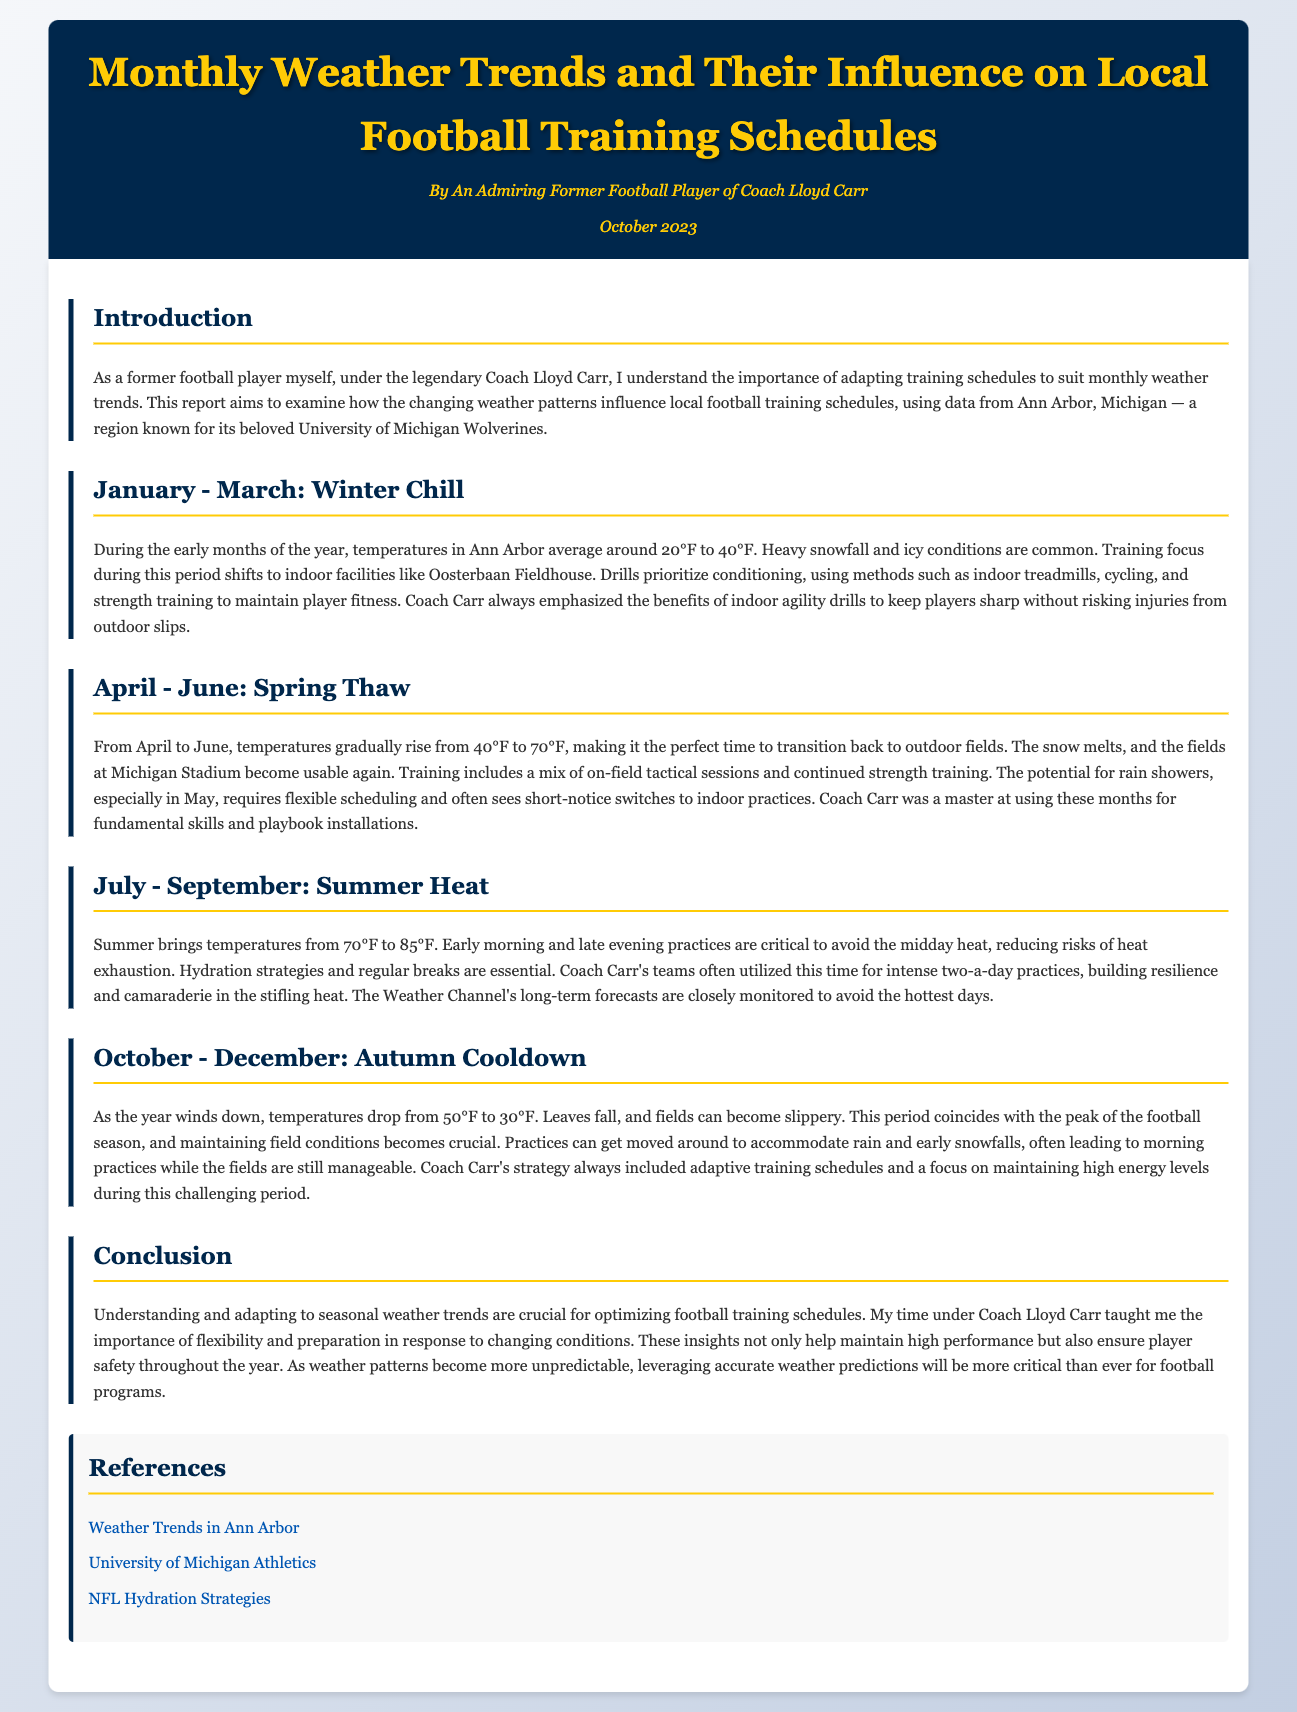What are the average temperatures during January to March? The document states that during January to March, temperatures in Ann Arbor average around 20°F to 40°F.
Answer: 20°F to 40°F Which indoor facility is mentioned for winter training? The report mentions Oosterbaan Fieldhouse as the indoor facility for winter training.
Answer: Oosterbaan Fieldhouse What is the training focus from April to June? The training focus during April to June includes a mix of on-field tactical sessions and continued strength training.
Answer: On-field tactical sessions and continued strength training What temperatures are typically present in July and September? The document indicates that summer brings temperatures from 70°F to 85°F.
Answer: 70°F to 85°F What does Coach Carr emphasize during summer training? The report mentions that Coach Carr emphasized hydration strategies and regular breaks during summer training.
Answer: Hydration strategies and regular breaks What significant weather condition affects training in October to December? The document highlights that leaves falling and slippery conditions can affect training during this period.
Answer: Slippery conditions How does the document suggest adapting training schedules? The conclusion mentions the importance of understanding and adapting to seasonal weather trends for optimizing training schedules.
Answer: Adapting to seasonal weather trends What is the main takeaway from the report? The report concludes that leveraging accurate weather predictions will be critical for football programs as conditions become more unpredictable.
Answer: Accurate weather predictions are critical 